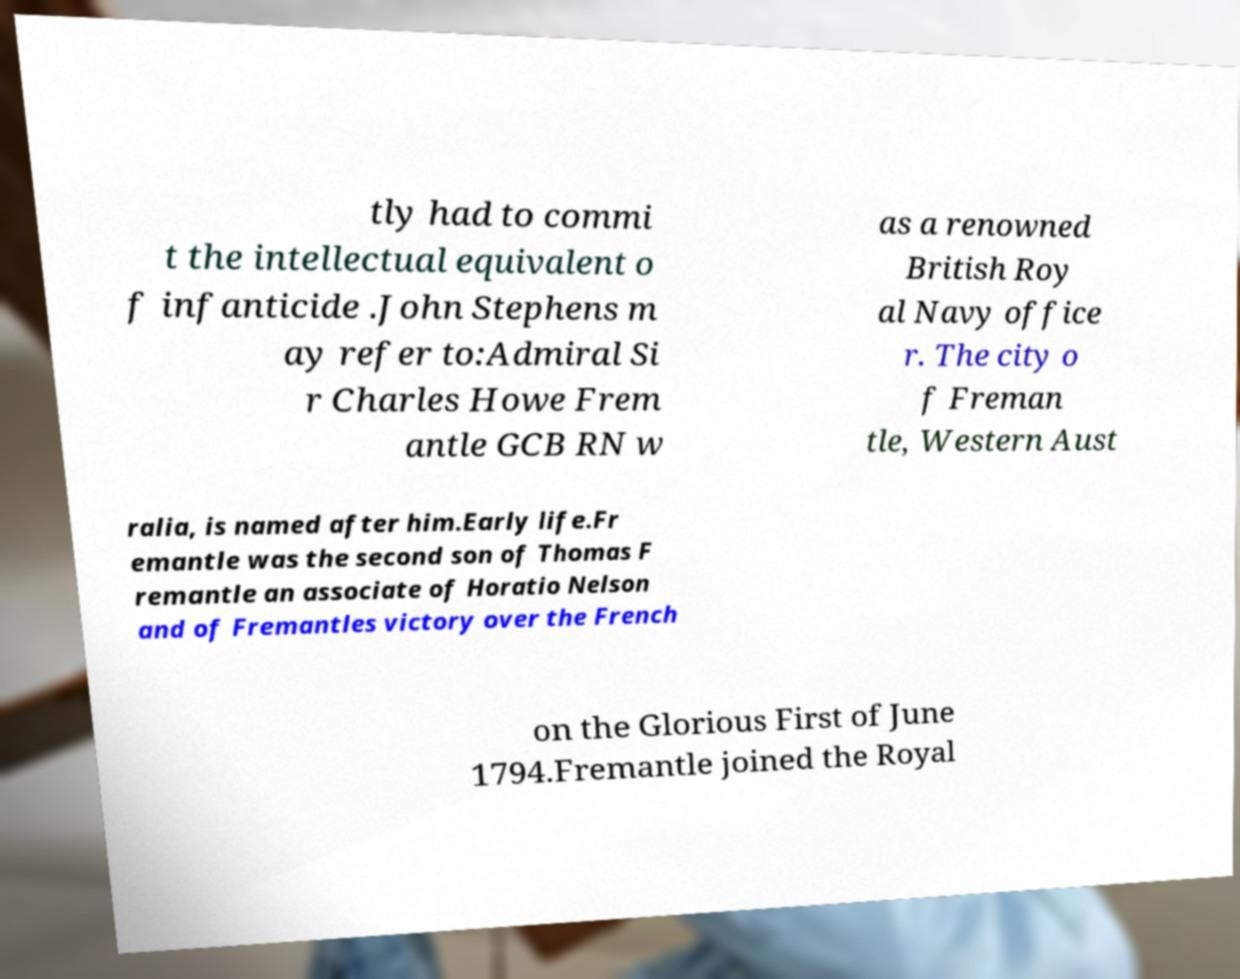Can you accurately transcribe the text from the provided image for me? tly had to commi t the intellectual equivalent o f infanticide .John Stephens m ay refer to:Admiral Si r Charles Howe Frem antle GCB RN w as a renowned British Roy al Navy office r. The city o f Freman tle, Western Aust ralia, is named after him.Early life.Fr emantle was the second son of Thomas F remantle an associate of Horatio Nelson and of Fremantles victory over the French on the Glorious First of June 1794.Fremantle joined the Royal 